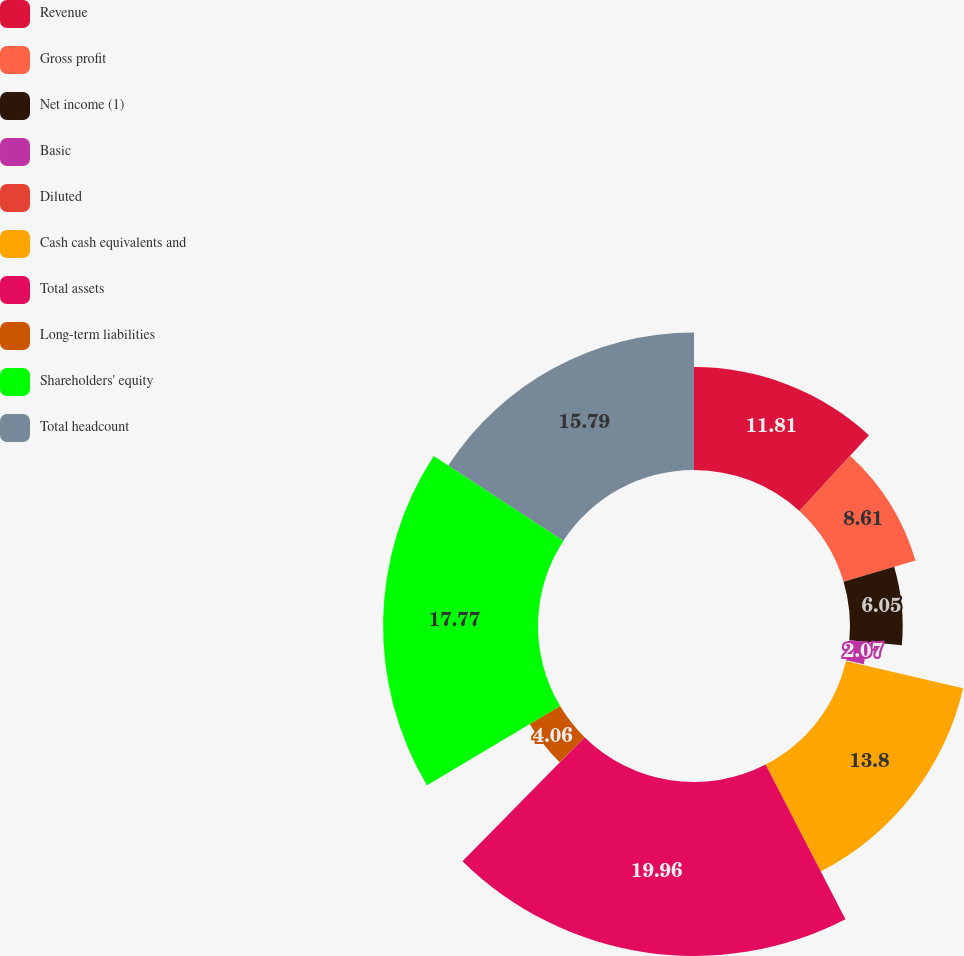Convert chart. <chart><loc_0><loc_0><loc_500><loc_500><pie_chart><fcel>Revenue<fcel>Gross profit<fcel>Net income (1)<fcel>Basic<fcel>Diluted<fcel>Cash cash equivalents and<fcel>Total assets<fcel>Long-term liabilities<fcel>Shareholders' equity<fcel>Total headcount<nl><fcel>11.81%<fcel>8.61%<fcel>6.05%<fcel>2.07%<fcel>0.08%<fcel>13.8%<fcel>19.97%<fcel>4.06%<fcel>17.78%<fcel>15.79%<nl></chart> 